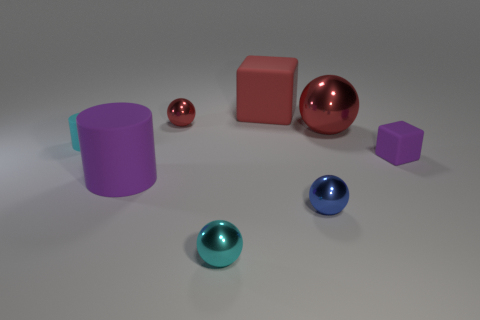How many metal balls have the same color as the small cylinder?
Your answer should be compact. 1. The small rubber object behind the rubber object that is right of the blue thing is what color?
Your answer should be compact. Cyan. What size is the cyan object that is the same shape as the small red metal thing?
Offer a very short reply. Small. Is the large cylinder the same color as the large block?
Ensure brevity in your answer.  No. How many big rubber things are right of the small cyan thing that is right of the large purple thing that is left of the tiny blue metal sphere?
Give a very brief answer. 1. Are there more big blue objects than tiny purple blocks?
Your response must be concise. No. How many large red rubber balls are there?
Your answer should be compact. 0. What is the shape of the big red object that is in front of the block behind the purple object right of the big purple thing?
Offer a very short reply. Sphere. Are there fewer big purple matte things that are behind the small rubber cylinder than purple cylinders that are left of the big purple thing?
Your response must be concise. No. There is a purple matte object in front of the tiny purple object; is its shape the same as the small cyan object that is behind the large purple cylinder?
Offer a very short reply. Yes. 